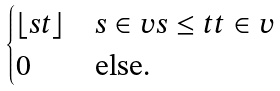Convert formula to latex. <formula><loc_0><loc_0><loc_500><loc_500>\begin{cases} \lfloor s t \rfloor & s \in v s \leq t t \in v \\ 0 & \text {else.} \end{cases}</formula> 